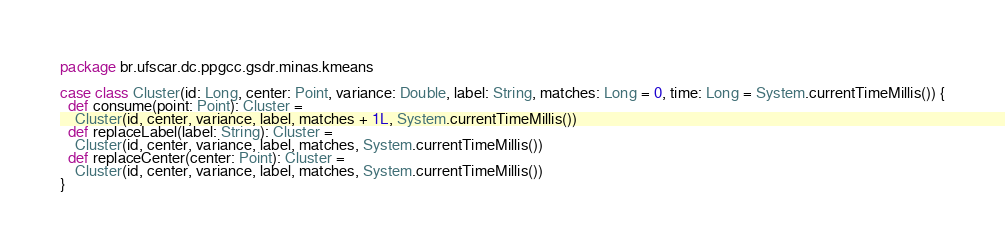<code> <loc_0><loc_0><loc_500><loc_500><_Scala_>package br.ufscar.dc.ppgcc.gsdr.minas.kmeans

case class Cluster(id: Long, center: Point, variance: Double, label: String, matches: Long = 0, time: Long = System.currentTimeMillis()) {
  def consume(point: Point): Cluster =
    Cluster(id, center, variance, label, matches + 1L, System.currentTimeMillis())
  def replaceLabel(label: String): Cluster =
    Cluster(id, center, variance, label, matches, System.currentTimeMillis())
  def replaceCenter(center: Point): Cluster =
    Cluster(id, center, variance, label, matches, System.currentTimeMillis())
}
</code> 